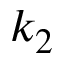<formula> <loc_0><loc_0><loc_500><loc_500>k _ { 2 }</formula> 